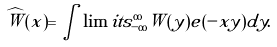Convert formula to latex. <formula><loc_0><loc_0><loc_500><loc_500>\widehat { W } ( x ) = \int \lim i t s ^ { \infty } _ { - \infty } W ( y ) e ( - x y ) d y .</formula> 